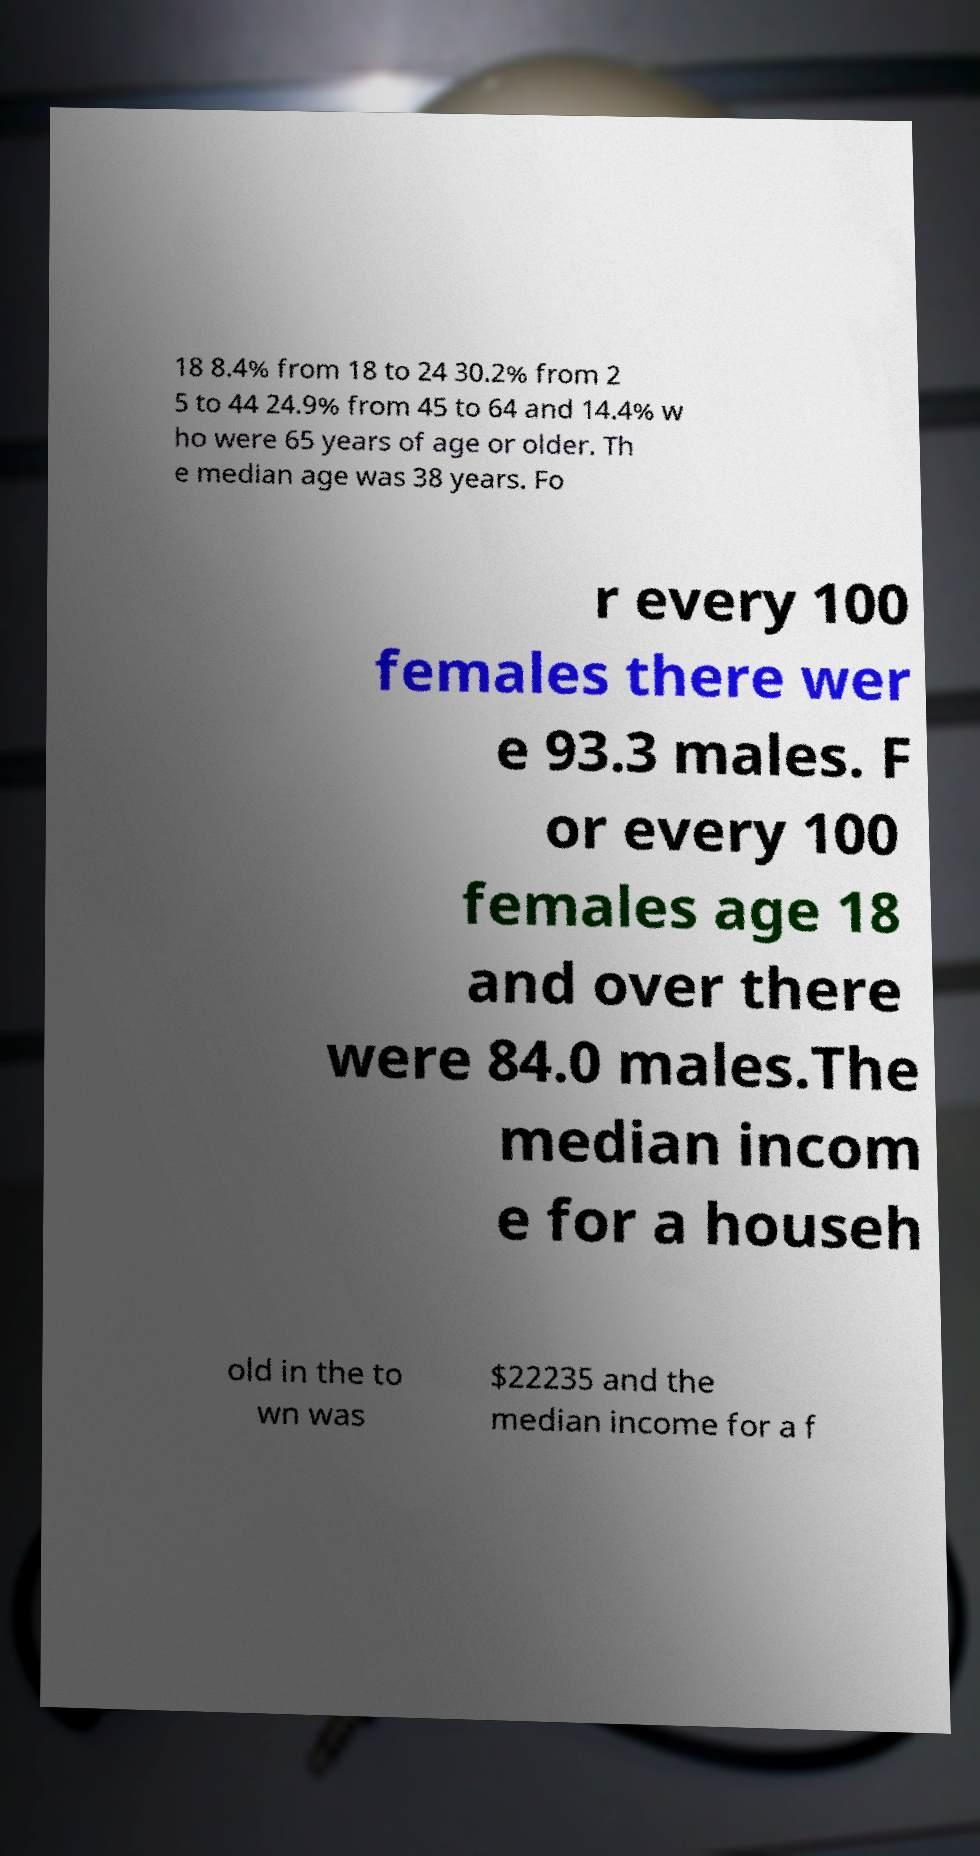Could you extract and type out the text from this image? 18 8.4% from 18 to 24 30.2% from 2 5 to 44 24.9% from 45 to 64 and 14.4% w ho were 65 years of age or older. Th e median age was 38 years. Fo r every 100 females there wer e 93.3 males. F or every 100 females age 18 and over there were 84.0 males.The median incom e for a househ old in the to wn was $22235 and the median income for a f 